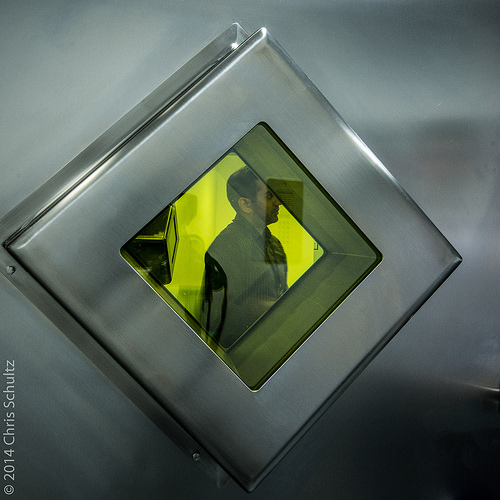<image>
Can you confirm if the man is in the glass? Yes. The man is contained within or inside the glass, showing a containment relationship. 